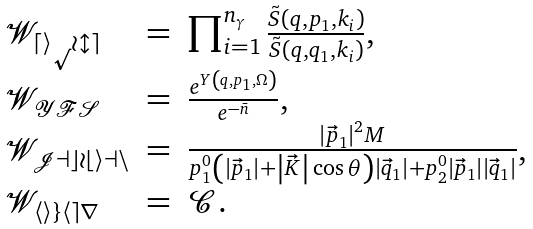<formula> <loc_0><loc_0><loc_500><loc_500>\begin{array} { l c l } \mathcal { W _ { d i p o l e } } & = & \prod _ { i = 1 } ^ { n _ { \gamma } } \frac { \tilde { S } \left ( q , p _ { 1 } , k _ { i } \right ) } { \tilde { S } \left ( q , q _ { 1 } , k _ { i } \right ) } , \\ \mathcal { W _ { Y F S } } & = & \frac { e ^ { Y \left ( q , p _ { 1 } , \Omega \right ) } } { e ^ { - \bar { n } } } , \\ \mathcal { W _ { J a c o b i a n } } & = & \frac { \left | \vec { p } _ { 1 } \right | ^ { 2 } M } { p _ { 1 } ^ { 0 } \left ( \left | \vec { p } _ { 1 } \right | + \left | \vec { K } \right | \cos \theta \right ) \left | \vec { q } _ { 1 } \right | + p _ { 2 } ^ { 0 } \left | \vec { p } _ { 1 } \right | \left | \vec { q } _ { 1 } \right | } , \\ \mathcal { W _ { h i g h e r } } & = & \mathcal { C } . \end{array}</formula> 